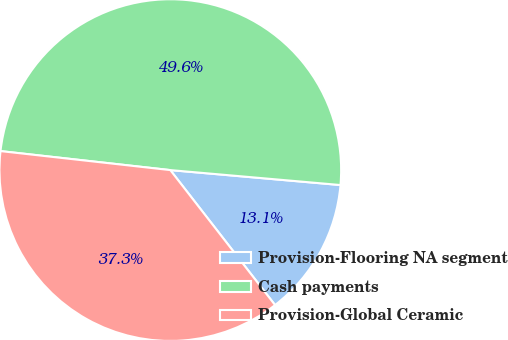<chart> <loc_0><loc_0><loc_500><loc_500><pie_chart><fcel>Provision-Flooring NA segment<fcel>Cash payments<fcel>Provision-Global Ceramic<nl><fcel>13.1%<fcel>49.62%<fcel>37.28%<nl></chart> 